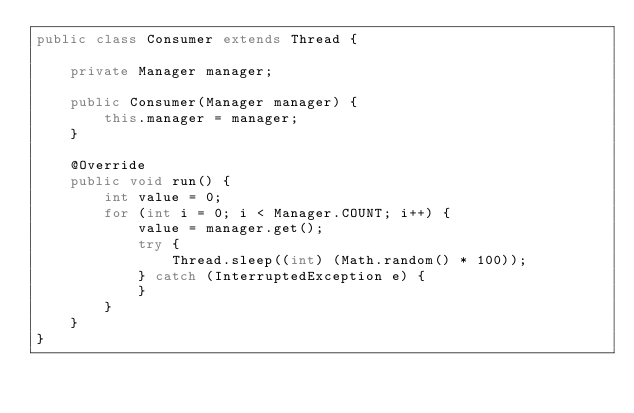<code> <loc_0><loc_0><loc_500><loc_500><_Java_>public class Consumer extends Thread {

    private Manager manager;

    public Consumer(Manager manager) {
        this.manager = manager;
    }

    @Override
    public void run() {
        int value = 0;
        for (int i = 0; i < Manager.COUNT; i++) {
            value = manager.get();
            try {
                Thread.sleep((int) (Math.random() * 100));
            } catch (InterruptedException e) {
            }
        }
    }
}
</code> 